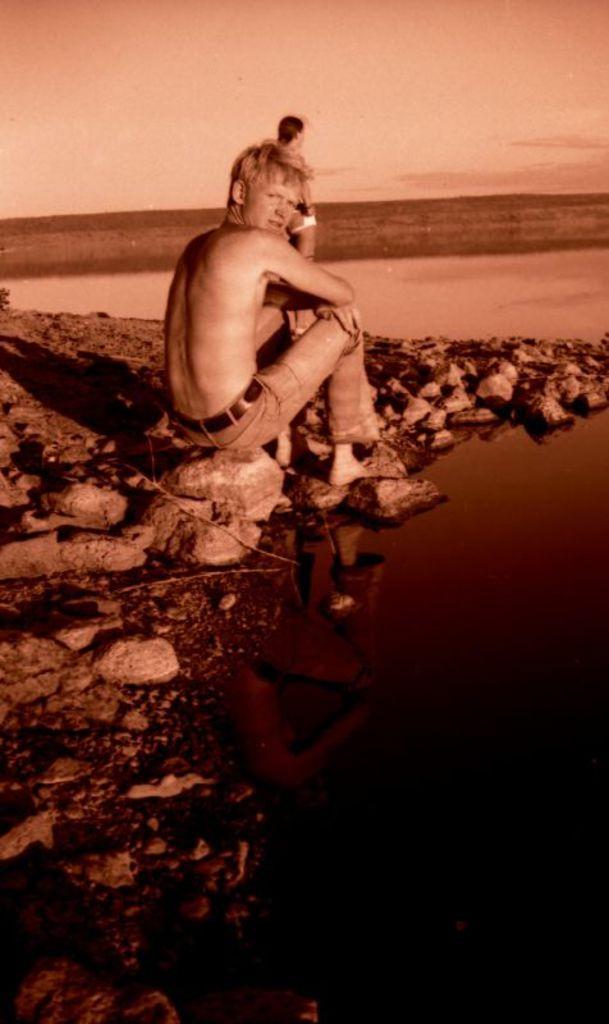How would you summarize this image in a sentence or two? There is water. On the side of the water there are rocks. And a person is sitting on that. In the back there is another person standing. In the background there is sky. 